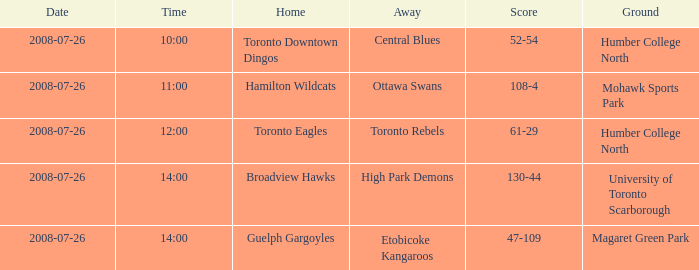At humber college north's ground at 12:00, what was the away? Toronto Rebels. 